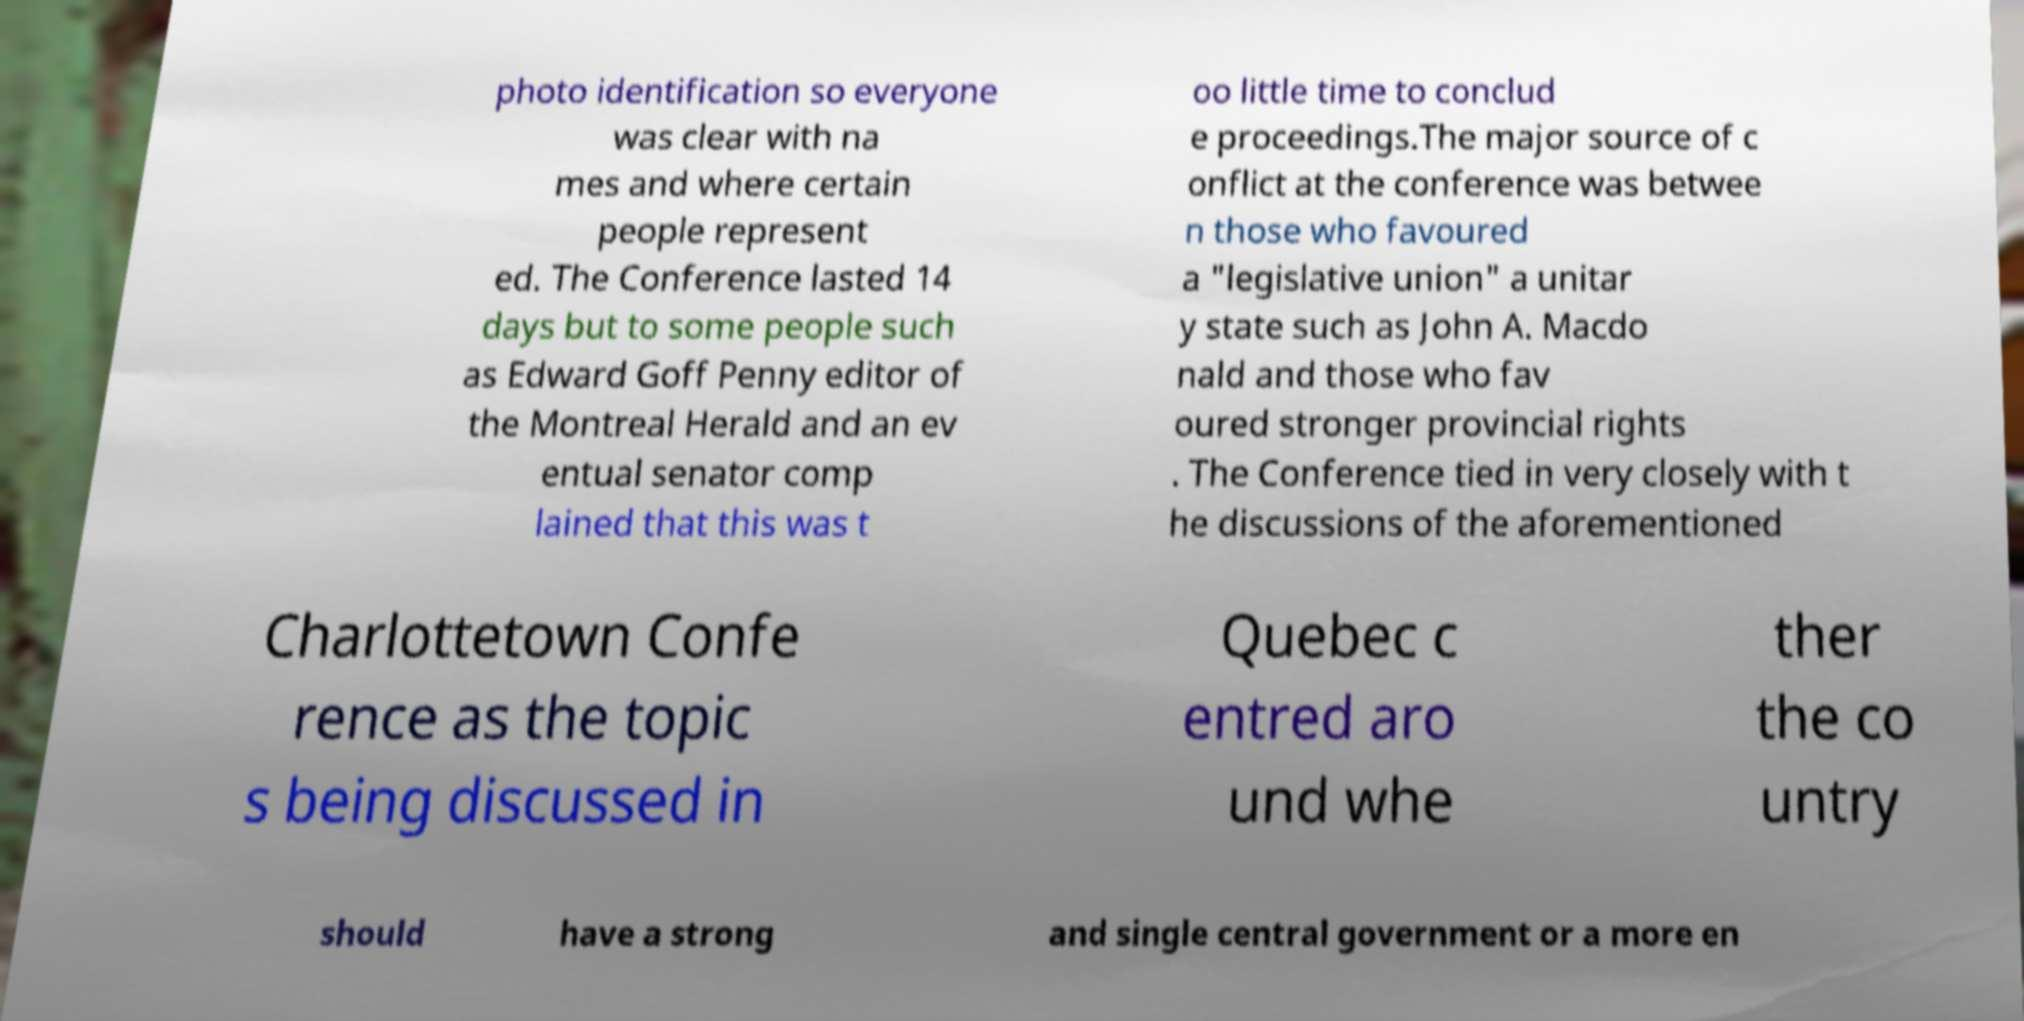What messages or text are displayed in this image? I need them in a readable, typed format. photo identification so everyone was clear with na mes and where certain people represent ed. The Conference lasted 14 days but to some people such as Edward Goff Penny editor of the Montreal Herald and an ev entual senator comp lained that this was t oo little time to conclud e proceedings.The major source of c onflict at the conference was betwee n those who favoured a "legislative union" a unitar y state such as John A. Macdo nald and those who fav oured stronger provincial rights . The Conference tied in very closely with t he discussions of the aforementioned Charlottetown Confe rence as the topic s being discussed in Quebec c entred aro und whe ther the co untry should have a strong and single central government or a more en 